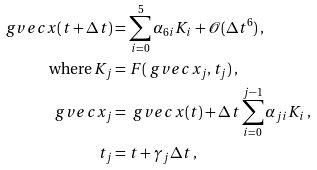Convert formula to latex. <formula><loc_0><loc_0><loc_500><loc_500>\ g v e c { x } ( t + \Delta t ) & = \sum _ { i = 0 } ^ { 5 } \alpha _ { 6 i } K _ { i } + \mathcal { O } ( \Delta t ^ { 6 } ) \, , \\ \text {where} \, K _ { j } & = F ( \ g v e c { x } _ { j } , t _ { j } ) \, , \\ \ g v e c { x } _ { j } & = \ g v e c { x } ( t ) + \Delta t \sum _ { i = 0 } ^ { j - 1 } \alpha _ { j i } K _ { i } \, , \\ t _ { j } & = t + \gamma _ { j } \Delta t \, ,</formula> 